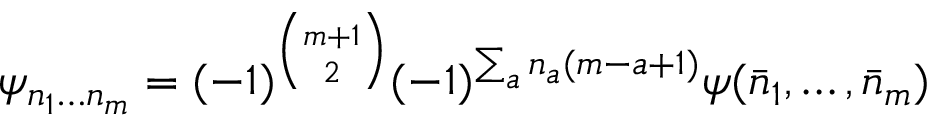Convert formula to latex. <formula><loc_0><loc_0><loc_500><loc_500>\psi _ { n _ { 1 } \dots n _ { m } } = ( - 1 ) ^ { { \binom { m + 1 } { 2 } } } ( - 1 ) ^ { \sum _ { a } n _ { a } ( m - a + 1 ) } \psi ( \bar { n } _ { 1 } , \dots , \bar { n } _ { m } )</formula> 